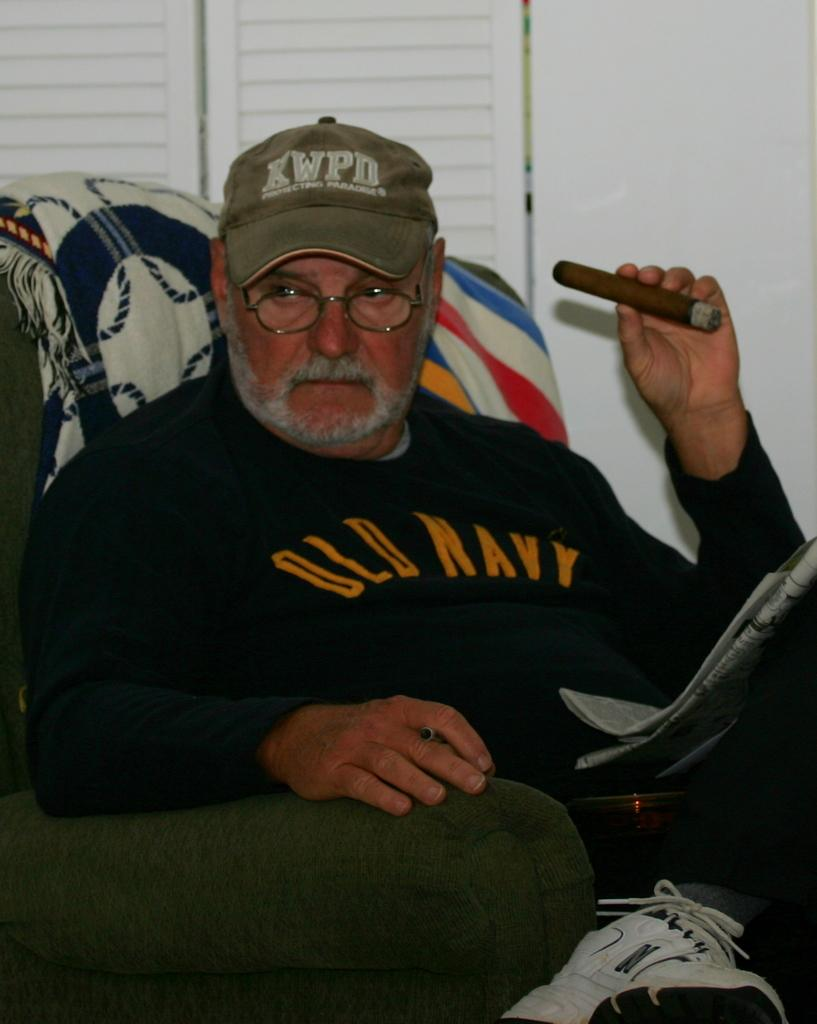<image>
Write a terse but informative summary of the picture. A man in an Old Navy sweater smokes a cigar. 